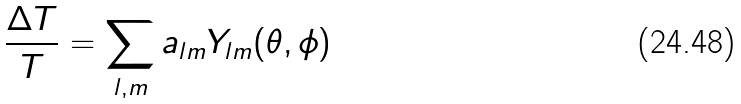Convert formula to latex. <formula><loc_0><loc_0><loc_500><loc_500>\frac { \Delta T } { T } = \sum _ { l , m } a _ { l m } Y _ { l m } ( \theta , \phi )</formula> 